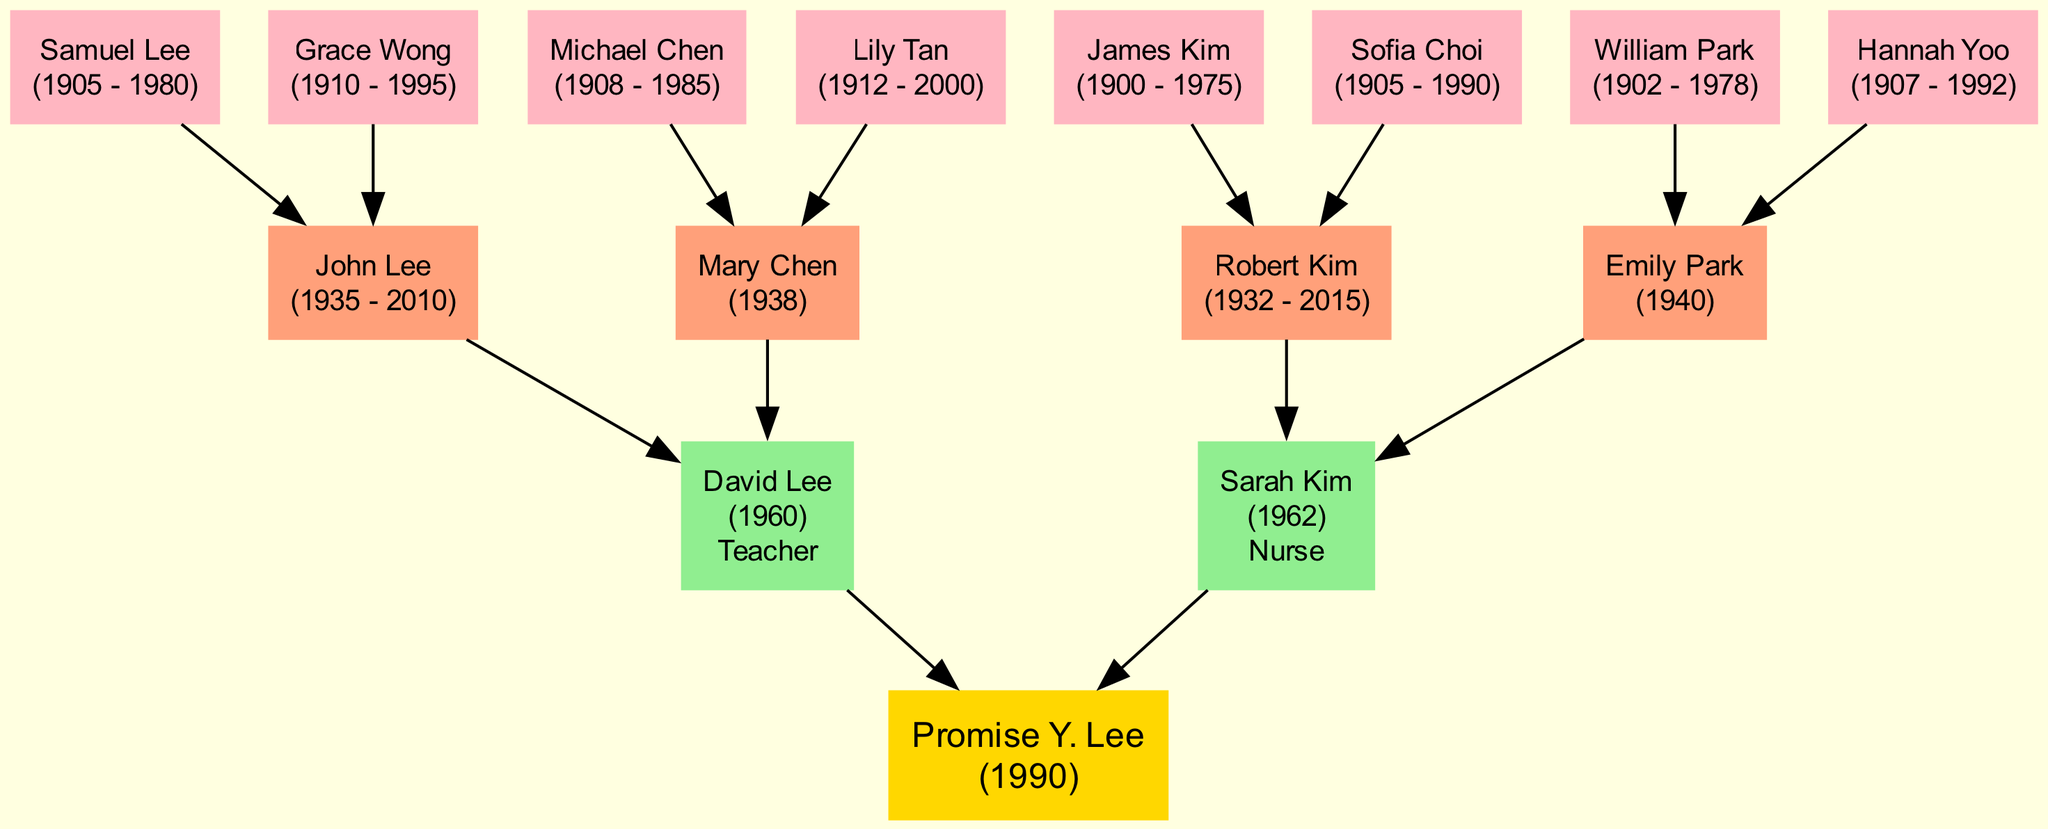What is the birth year of Promise Y. Lee? The diagram identifies Promise Y. Lee as the root node and shows her birth year in parentheses. It states "Promise Y. Lee (1990)", indicating that her birth year is 1990.
Answer: 1990 How many parents does Promise Y. Lee have? In the diagram, under the root node, there are two parent nodes connected to Promise Y. Lee. Counting those nodes shows that she has two parents.
Answer: 2 Who is the mother of Promise Y. Lee? The diagram lists two parents and provides their names. Sarah Kim is indicated as the second parent listed, suggesting she is the mother since the first parent listed, David Lee, is most likely the father.
Answer: Sarah Kim What are the occupations of Promise Y. Lee's parents? The diagram shows the names and occupations of both parents. David Lee is labeled "Teacher" and Sarah Kim is labeled "Nurse". Listing both together provides the respective occupations of Promise's parents.
Answer: Teacher, Nurse How many grandparents does Promise Y. Lee have? There are four nodes directly connected to Promise's parents indicating her grandparents. Counting these nodes shows four grandparents in total.
Answer: 4 Who are the paternal grandparents of Promise Y. Lee? The paternal grandparents are connected to the parent node that corresponds to David Lee. The grandparents directly listed are John Lee and Mary Chen. Thus, these two are the paternal grandparents.
Answer: John Lee, Mary Chen Which great-grandparent was born in 1900? The sixth node of great-grandparents lists "James Kim (1900 - 1975)". By reviewing the birth years provided for each great-grandparent, James Kim is identified as the one who was born in 1900.
Answer: James Kim What is the birth year of Emily Park? In the grandparent section of the diagram, Emily Park is identified and her birth year is stated as 1940. This information is found directly beneath her name in the node.
Answer: 1940 Who is the maternal grandmother of Promise Y. Lee? Looking at the mother’s lineage, Sarah Kim has two parents listed. Robert Kim is the father, and Emily Park is the mother; therefore, Emily Park is the maternal grandmother.
Answer: Emily Park 